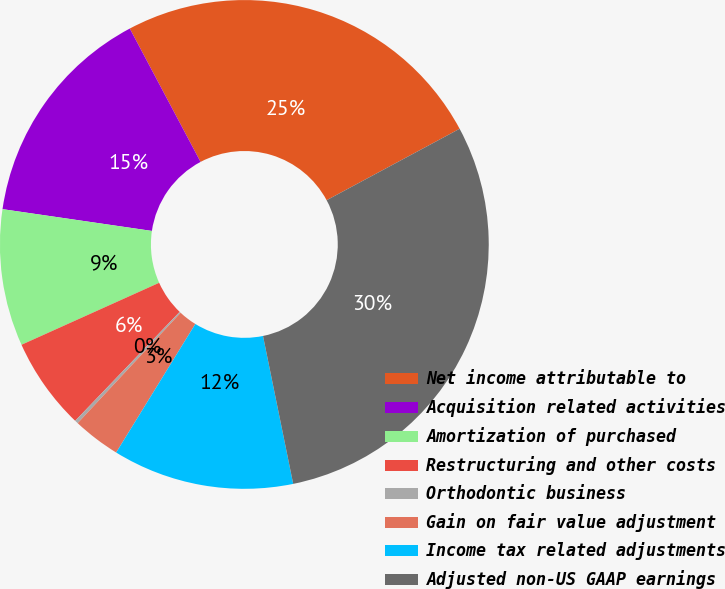Convert chart to OTSL. <chart><loc_0><loc_0><loc_500><loc_500><pie_chart><fcel>Net income attributable to<fcel>Acquisition related activities<fcel>Amortization of purchased<fcel>Restructuring and other costs<fcel>Orthodontic business<fcel>Gain on fair value adjustment<fcel>Income tax related adjustments<fcel>Adjusted non-US GAAP earnings<nl><fcel>24.92%<fcel>14.93%<fcel>9.04%<fcel>6.1%<fcel>0.22%<fcel>3.16%<fcel>11.99%<fcel>29.64%<nl></chart> 